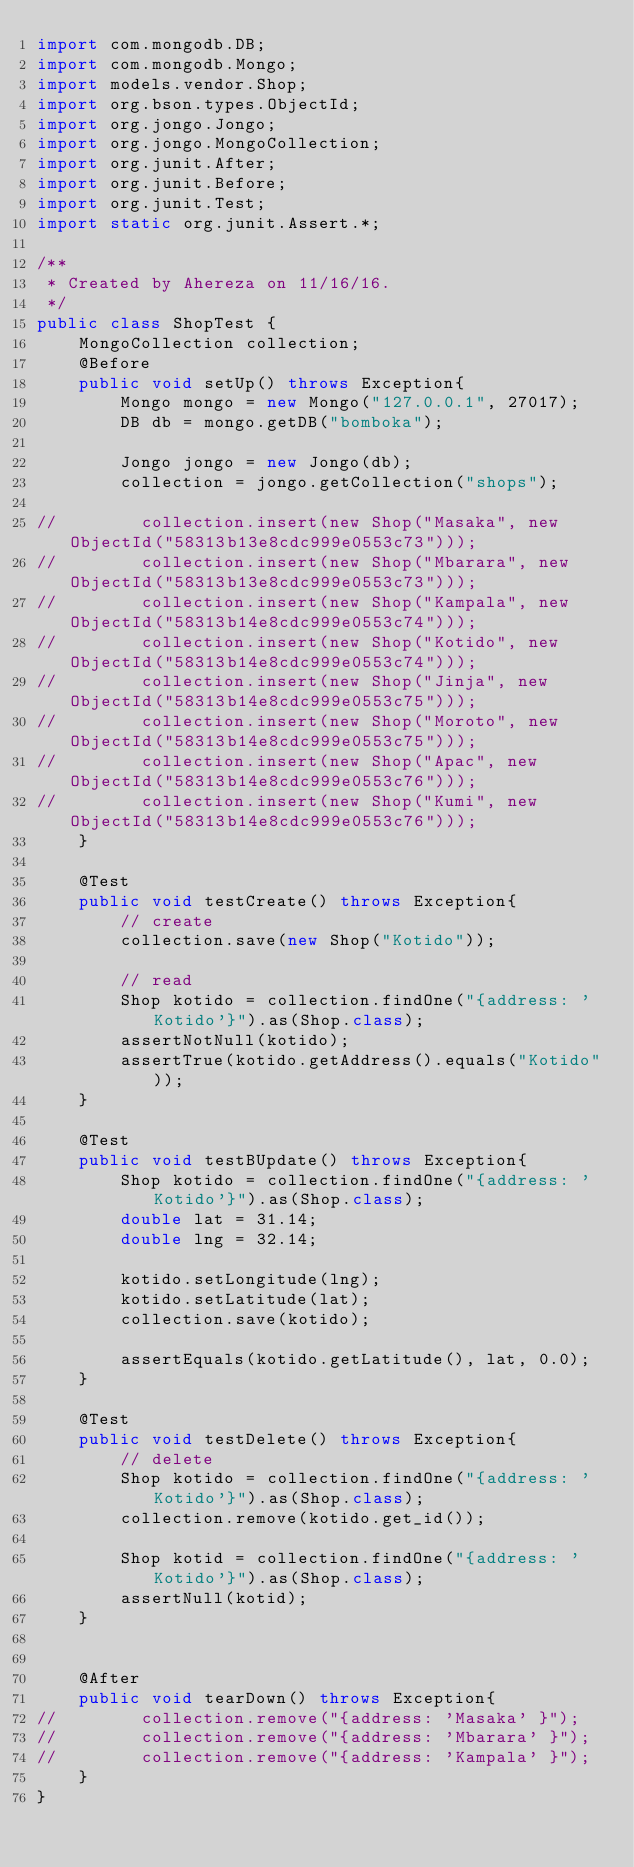Convert code to text. <code><loc_0><loc_0><loc_500><loc_500><_Java_>import com.mongodb.DB;
import com.mongodb.Mongo;
import models.vendor.Shop;
import org.bson.types.ObjectId;
import org.jongo.Jongo;
import org.jongo.MongoCollection;
import org.junit.After;
import org.junit.Before;
import org.junit.Test;
import static org.junit.Assert.*;

/**
 * Created by Ahereza on 11/16/16.
 */
public class ShopTest {
    MongoCollection collection;
    @Before
    public void setUp() throws Exception{
        Mongo mongo = new Mongo("127.0.0.1", 27017);
        DB db = mongo.getDB("bomboka");

        Jongo jongo = new Jongo(db);
        collection = jongo.getCollection("shops");

//        collection.insert(new Shop("Masaka", new ObjectId("58313b13e8cdc999e0553c73")));
//        collection.insert(new Shop("Mbarara", new ObjectId("58313b13e8cdc999e0553c73")));
//        collection.insert(new Shop("Kampala", new ObjectId("58313b14e8cdc999e0553c74")));
//        collection.insert(new Shop("Kotido", new ObjectId("58313b14e8cdc999e0553c74")));
//        collection.insert(new Shop("Jinja", new ObjectId("58313b14e8cdc999e0553c75")));
//        collection.insert(new Shop("Moroto", new ObjectId("58313b14e8cdc999e0553c75")));
//        collection.insert(new Shop("Apac", new ObjectId("58313b14e8cdc999e0553c76")));
//        collection.insert(new Shop("Kumi", new ObjectId("58313b14e8cdc999e0553c76")));
    }

    @Test
    public void testCreate() throws Exception{
        // create
        collection.save(new Shop("Kotido"));

        // read
        Shop kotido = collection.findOne("{address: 'Kotido'}").as(Shop.class);
        assertNotNull(kotido);
        assertTrue(kotido.getAddress().equals("Kotido"));
    }

    @Test
    public void testBUpdate() throws Exception{
        Shop kotido = collection.findOne("{address: 'Kotido'}").as(Shop.class);
        double lat = 31.14;
        double lng = 32.14;

        kotido.setLongitude(lng);
        kotido.setLatitude(lat);
        collection.save(kotido);

        assertEquals(kotido.getLatitude(), lat, 0.0);
    }

    @Test
    public void testDelete() throws Exception{
        // delete
        Shop kotido = collection.findOne("{address: 'Kotido'}").as(Shop.class);
        collection.remove(kotido.get_id());

        Shop kotid = collection.findOne("{address: 'Kotido'}").as(Shop.class);
        assertNull(kotid);
    }


    @After
    public void tearDown() throws Exception{
//        collection.remove("{address: 'Masaka' }");
//        collection.remove("{address: 'Mbarara' }");
//        collection.remove("{address: 'Kampala' }");
    }
}
</code> 